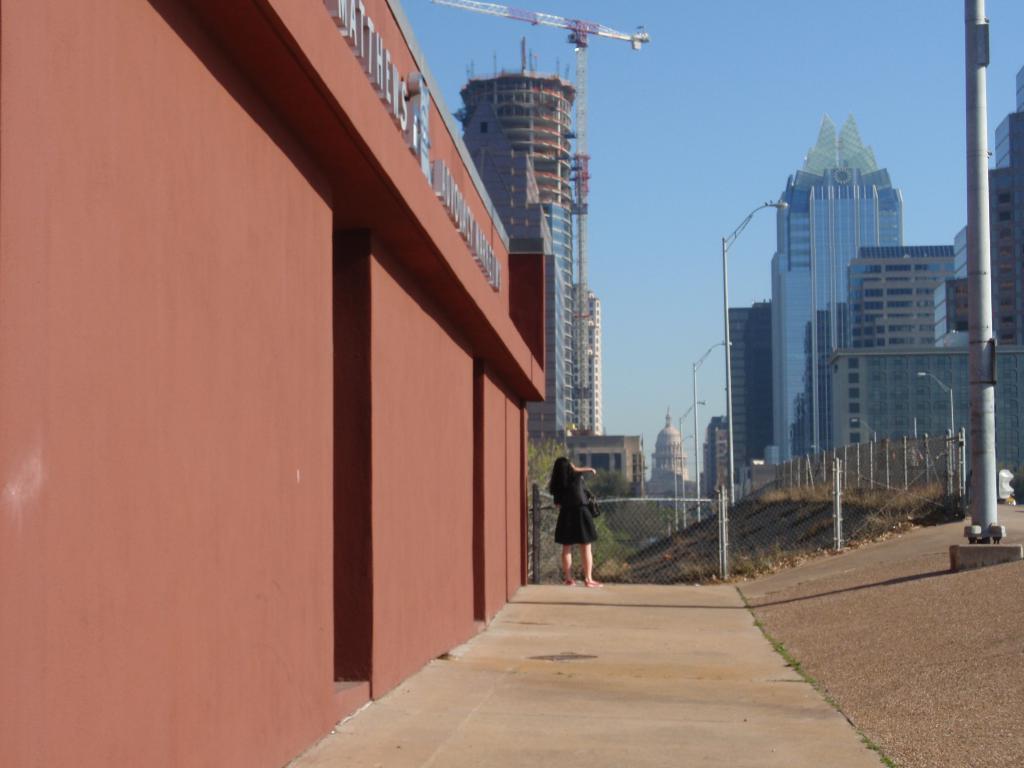In one or two sentences, can you explain what this image depicts? In this image I can see the building which is in brown color. In-front of the building I can see the person with black color dress. To the side of person I can see the railing and many poles. In the background I can see the tree, crane, few more buildings and the sky. 